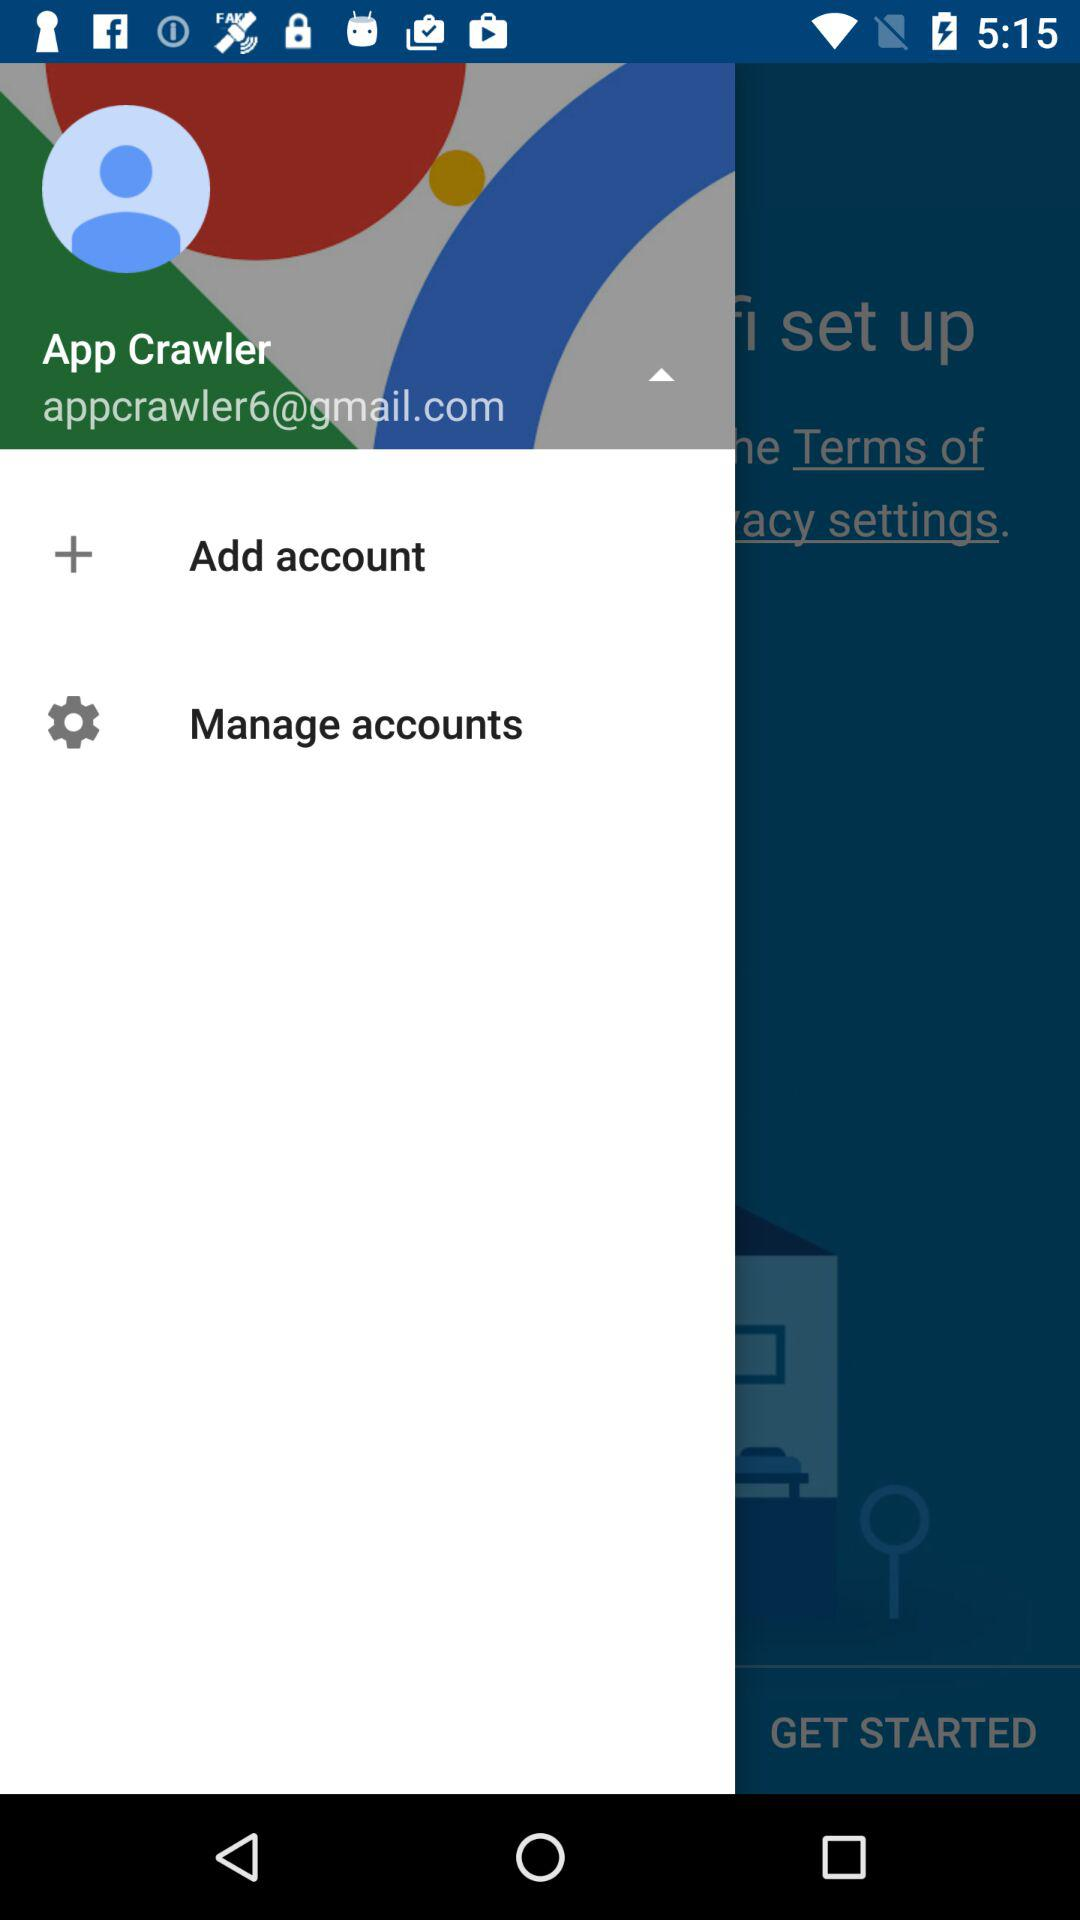How many notifications are there in "Manage accounts"?
When the provided information is insufficient, respond with <no answer>. <no answer> 